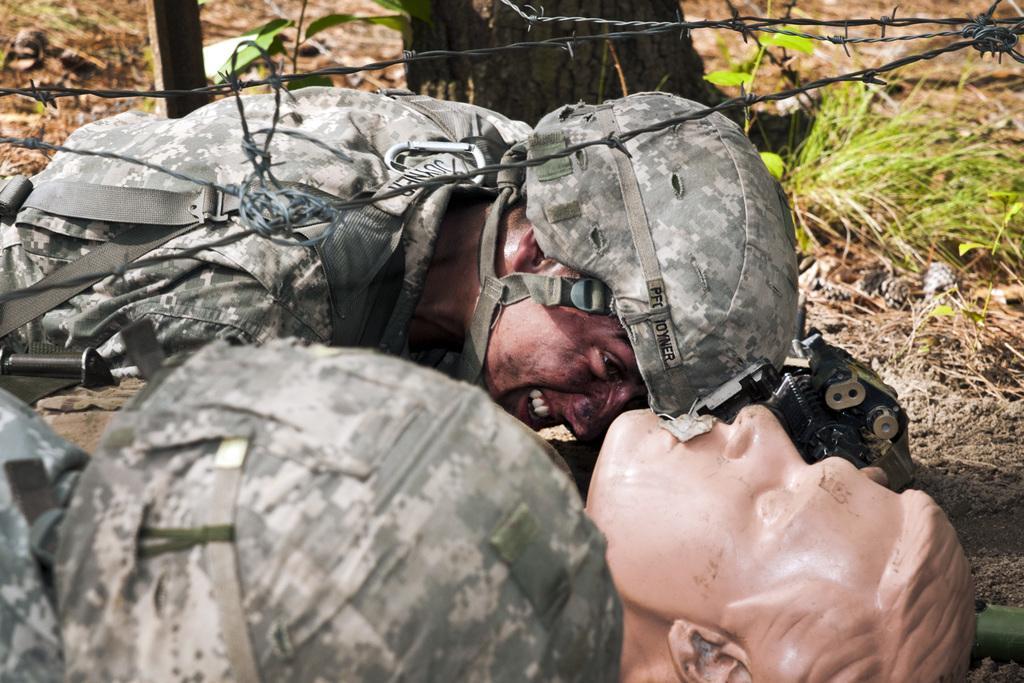In one or two sentences, can you explain what this image depicts? In this picture we can see a statue of a person and a man on the ground and in the background we can see grass and some objects. 